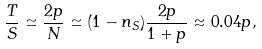Convert formula to latex. <formula><loc_0><loc_0><loc_500><loc_500>\frac { T } { S } \simeq \frac { 2 p } { N } \simeq ( 1 - n _ { S } ) \frac { 2 p } { 1 + p } \approx 0 . 0 4 p ,</formula> 